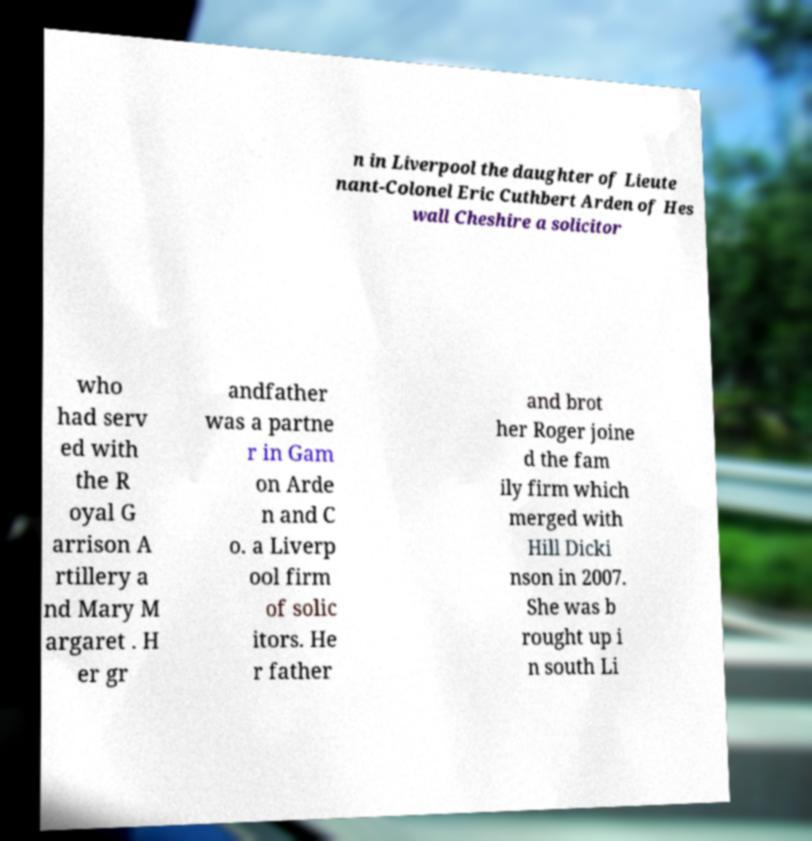For documentation purposes, I need the text within this image transcribed. Could you provide that? n in Liverpool the daughter of Lieute nant-Colonel Eric Cuthbert Arden of Hes wall Cheshire a solicitor who had serv ed with the R oyal G arrison A rtillery a nd Mary M argaret . H er gr andfather was a partne r in Gam on Arde n and C o. a Liverp ool firm of solic itors. He r father and brot her Roger joine d the fam ily firm which merged with Hill Dicki nson in 2007. She was b rought up i n south Li 